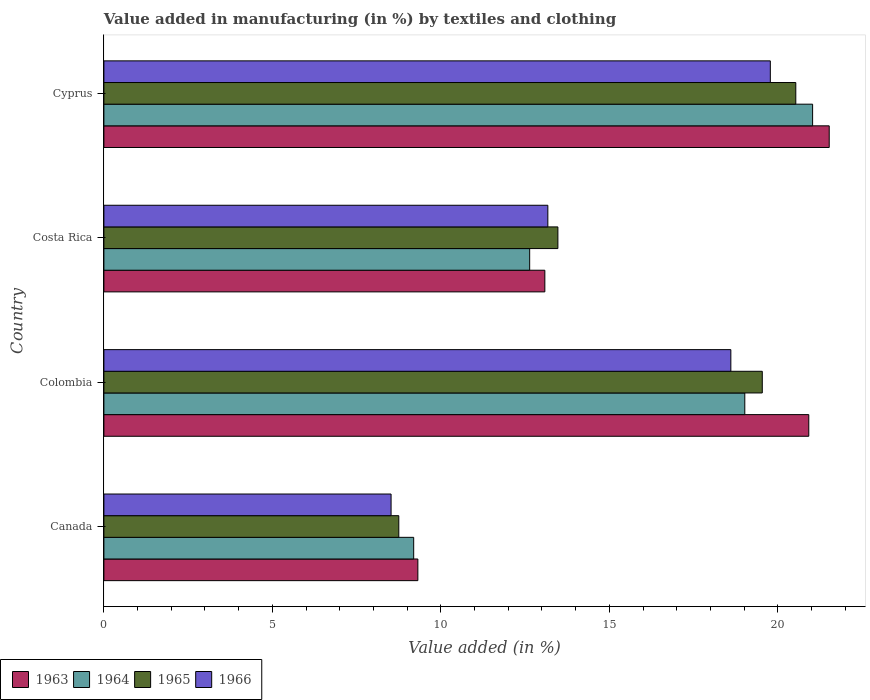Are the number of bars on each tick of the Y-axis equal?
Offer a terse response. Yes. How many bars are there on the 1st tick from the top?
Keep it short and to the point. 4. How many bars are there on the 3rd tick from the bottom?
Offer a terse response. 4. What is the label of the 3rd group of bars from the top?
Your answer should be very brief. Colombia. What is the percentage of value added in manufacturing by textiles and clothing in 1964 in Cyprus?
Ensure brevity in your answer.  21.03. Across all countries, what is the maximum percentage of value added in manufacturing by textiles and clothing in 1965?
Offer a terse response. 20.53. Across all countries, what is the minimum percentage of value added in manufacturing by textiles and clothing in 1964?
Keep it short and to the point. 9.19. In which country was the percentage of value added in manufacturing by textiles and clothing in 1963 maximum?
Your answer should be very brief. Cyprus. In which country was the percentage of value added in manufacturing by textiles and clothing in 1963 minimum?
Give a very brief answer. Canada. What is the total percentage of value added in manufacturing by textiles and clothing in 1963 in the graph?
Your answer should be very brief. 64.84. What is the difference between the percentage of value added in manufacturing by textiles and clothing in 1966 in Colombia and that in Cyprus?
Make the answer very short. -1.17. What is the difference between the percentage of value added in manufacturing by textiles and clothing in 1963 in Colombia and the percentage of value added in manufacturing by textiles and clothing in 1964 in Costa Rica?
Offer a very short reply. 8.28. What is the average percentage of value added in manufacturing by textiles and clothing in 1964 per country?
Provide a short and direct response. 15.47. What is the difference between the percentage of value added in manufacturing by textiles and clothing in 1966 and percentage of value added in manufacturing by textiles and clothing in 1964 in Colombia?
Your answer should be very brief. -0.41. In how many countries, is the percentage of value added in manufacturing by textiles and clothing in 1963 greater than 16 %?
Provide a succinct answer. 2. What is the ratio of the percentage of value added in manufacturing by textiles and clothing in 1964 in Colombia to that in Cyprus?
Your answer should be compact. 0.9. Is the difference between the percentage of value added in manufacturing by textiles and clothing in 1966 in Canada and Cyprus greater than the difference between the percentage of value added in manufacturing by textiles and clothing in 1964 in Canada and Cyprus?
Keep it short and to the point. Yes. What is the difference between the highest and the second highest percentage of value added in manufacturing by textiles and clothing in 1964?
Ensure brevity in your answer.  2.01. What is the difference between the highest and the lowest percentage of value added in manufacturing by textiles and clothing in 1965?
Offer a terse response. 11.78. In how many countries, is the percentage of value added in manufacturing by textiles and clothing in 1966 greater than the average percentage of value added in manufacturing by textiles and clothing in 1966 taken over all countries?
Give a very brief answer. 2. Is the sum of the percentage of value added in manufacturing by textiles and clothing in 1966 in Canada and Colombia greater than the maximum percentage of value added in manufacturing by textiles and clothing in 1964 across all countries?
Provide a short and direct response. Yes. What does the 1st bar from the top in Cyprus represents?
Provide a succinct answer. 1966. What does the 2nd bar from the bottom in Colombia represents?
Make the answer very short. 1964. Is it the case that in every country, the sum of the percentage of value added in manufacturing by textiles and clothing in 1964 and percentage of value added in manufacturing by textiles and clothing in 1963 is greater than the percentage of value added in manufacturing by textiles and clothing in 1966?
Your answer should be compact. Yes. How many bars are there?
Provide a succinct answer. 16. How many countries are there in the graph?
Offer a very short reply. 4. What is the difference between two consecutive major ticks on the X-axis?
Keep it short and to the point. 5. Are the values on the major ticks of X-axis written in scientific E-notation?
Your answer should be compact. No. Does the graph contain grids?
Provide a succinct answer. No. Where does the legend appear in the graph?
Your answer should be compact. Bottom left. How are the legend labels stacked?
Your answer should be very brief. Horizontal. What is the title of the graph?
Provide a succinct answer. Value added in manufacturing (in %) by textiles and clothing. Does "2000" appear as one of the legend labels in the graph?
Ensure brevity in your answer.  No. What is the label or title of the X-axis?
Your answer should be compact. Value added (in %). What is the label or title of the Y-axis?
Make the answer very short. Country. What is the Value added (in %) in 1963 in Canada?
Ensure brevity in your answer.  9.32. What is the Value added (in %) of 1964 in Canada?
Offer a very short reply. 9.19. What is the Value added (in %) of 1965 in Canada?
Offer a very short reply. 8.75. What is the Value added (in %) of 1966 in Canada?
Offer a very short reply. 8.52. What is the Value added (in %) in 1963 in Colombia?
Ensure brevity in your answer.  20.92. What is the Value added (in %) in 1964 in Colombia?
Your response must be concise. 19.02. What is the Value added (in %) in 1965 in Colombia?
Your answer should be compact. 19.54. What is the Value added (in %) in 1966 in Colombia?
Offer a terse response. 18.6. What is the Value added (in %) of 1963 in Costa Rica?
Offer a terse response. 13.08. What is the Value added (in %) in 1964 in Costa Rica?
Provide a succinct answer. 12.63. What is the Value added (in %) of 1965 in Costa Rica?
Offer a very short reply. 13.47. What is the Value added (in %) of 1966 in Costa Rica?
Offer a terse response. 13.17. What is the Value added (in %) of 1963 in Cyprus?
Provide a succinct answer. 21.52. What is the Value added (in %) of 1964 in Cyprus?
Your response must be concise. 21.03. What is the Value added (in %) of 1965 in Cyprus?
Make the answer very short. 20.53. What is the Value added (in %) in 1966 in Cyprus?
Provide a succinct answer. 19.78. Across all countries, what is the maximum Value added (in %) of 1963?
Offer a terse response. 21.52. Across all countries, what is the maximum Value added (in %) in 1964?
Your response must be concise. 21.03. Across all countries, what is the maximum Value added (in %) in 1965?
Your response must be concise. 20.53. Across all countries, what is the maximum Value added (in %) in 1966?
Ensure brevity in your answer.  19.78. Across all countries, what is the minimum Value added (in %) in 1963?
Keep it short and to the point. 9.32. Across all countries, what is the minimum Value added (in %) in 1964?
Your answer should be very brief. 9.19. Across all countries, what is the minimum Value added (in %) in 1965?
Your answer should be compact. 8.75. Across all countries, what is the minimum Value added (in %) of 1966?
Provide a short and direct response. 8.52. What is the total Value added (in %) of 1963 in the graph?
Offer a terse response. 64.84. What is the total Value added (in %) of 1964 in the graph?
Your response must be concise. 61.88. What is the total Value added (in %) in 1965 in the graph?
Make the answer very short. 62.29. What is the total Value added (in %) of 1966 in the graph?
Offer a terse response. 60.08. What is the difference between the Value added (in %) in 1963 in Canada and that in Colombia?
Offer a very short reply. -11.6. What is the difference between the Value added (in %) of 1964 in Canada and that in Colombia?
Make the answer very short. -9.82. What is the difference between the Value added (in %) of 1965 in Canada and that in Colombia?
Keep it short and to the point. -10.79. What is the difference between the Value added (in %) in 1966 in Canada and that in Colombia?
Give a very brief answer. -10.08. What is the difference between the Value added (in %) of 1963 in Canada and that in Costa Rica?
Your answer should be compact. -3.77. What is the difference between the Value added (in %) of 1964 in Canada and that in Costa Rica?
Provide a short and direct response. -3.44. What is the difference between the Value added (in %) of 1965 in Canada and that in Costa Rica?
Keep it short and to the point. -4.72. What is the difference between the Value added (in %) of 1966 in Canada and that in Costa Rica?
Give a very brief answer. -4.65. What is the difference between the Value added (in %) of 1963 in Canada and that in Cyprus?
Provide a succinct answer. -12.21. What is the difference between the Value added (in %) in 1964 in Canada and that in Cyprus?
Give a very brief answer. -11.84. What is the difference between the Value added (in %) in 1965 in Canada and that in Cyprus?
Ensure brevity in your answer.  -11.78. What is the difference between the Value added (in %) in 1966 in Canada and that in Cyprus?
Provide a succinct answer. -11.25. What is the difference between the Value added (in %) of 1963 in Colombia and that in Costa Rica?
Your response must be concise. 7.83. What is the difference between the Value added (in %) of 1964 in Colombia and that in Costa Rica?
Ensure brevity in your answer.  6.38. What is the difference between the Value added (in %) in 1965 in Colombia and that in Costa Rica?
Your answer should be compact. 6.06. What is the difference between the Value added (in %) in 1966 in Colombia and that in Costa Rica?
Give a very brief answer. 5.43. What is the difference between the Value added (in %) in 1963 in Colombia and that in Cyprus?
Offer a very short reply. -0.61. What is the difference between the Value added (in %) of 1964 in Colombia and that in Cyprus?
Offer a terse response. -2.01. What is the difference between the Value added (in %) in 1965 in Colombia and that in Cyprus?
Give a very brief answer. -0.99. What is the difference between the Value added (in %) in 1966 in Colombia and that in Cyprus?
Provide a short and direct response. -1.17. What is the difference between the Value added (in %) of 1963 in Costa Rica and that in Cyprus?
Give a very brief answer. -8.44. What is the difference between the Value added (in %) of 1964 in Costa Rica and that in Cyprus?
Offer a terse response. -8.4. What is the difference between the Value added (in %) in 1965 in Costa Rica and that in Cyprus?
Offer a terse response. -7.06. What is the difference between the Value added (in %) of 1966 in Costa Rica and that in Cyprus?
Your response must be concise. -6.6. What is the difference between the Value added (in %) in 1963 in Canada and the Value added (in %) in 1964 in Colombia?
Keep it short and to the point. -9.7. What is the difference between the Value added (in %) in 1963 in Canada and the Value added (in %) in 1965 in Colombia?
Your answer should be very brief. -10.22. What is the difference between the Value added (in %) in 1963 in Canada and the Value added (in %) in 1966 in Colombia?
Keep it short and to the point. -9.29. What is the difference between the Value added (in %) of 1964 in Canada and the Value added (in %) of 1965 in Colombia?
Provide a short and direct response. -10.34. What is the difference between the Value added (in %) in 1964 in Canada and the Value added (in %) in 1966 in Colombia?
Provide a succinct answer. -9.41. What is the difference between the Value added (in %) of 1965 in Canada and the Value added (in %) of 1966 in Colombia?
Provide a succinct answer. -9.85. What is the difference between the Value added (in %) of 1963 in Canada and the Value added (in %) of 1964 in Costa Rica?
Your answer should be compact. -3.32. What is the difference between the Value added (in %) of 1963 in Canada and the Value added (in %) of 1965 in Costa Rica?
Ensure brevity in your answer.  -4.16. What is the difference between the Value added (in %) in 1963 in Canada and the Value added (in %) in 1966 in Costa Rica?
Provide a short and direct response. -3.86. What is the difference between the Value added (in %) of 1964 in Canada and the Value added (in %) of 1965 in Costa Rica?
Provide a short and direct response. -4.28. What is the difference between the Value added (in %) of 1964 in Canada and the Value added (in %) of 1966 in Costa Rica?
Give a very brief answer. -3.98. What is the difference between the Value added (in %) of 1965 in Canada and the Value added (in %) of 1966 in Costa Rica?
Offer a very short reply. -4.42. What is the difference between the Value added (in %) in 1963 in Canada and the Value added (in %) in 1964 in Cyprus?
Offer a very short reply. -11.71. What is the difference between the Value added (in %) of 1963 in Canada and the Value added (in %) of 1965 in Cyprus?
Provide a succinct answer. -11.21. What is the difference between the Value added (in %) of 1963 in Canada and the Value added (in %) of 1966 in Cyprus?
Keep it short and to the point. -10.46. What is the difference between the Value added (in %) of 1964 in Canada and the Value added (in %) of 1965 in Cyprus?
Provide a short and direct response. -11.34. What is the difference between the Value added (in %) of 1964 in Canada and the Value added (in %) of 1966 in Cyprus?
Offer a terse response. -10.58. What is the difference between the Value added (in %) of 1965 in Canada and the Value added (in %) of 1966 in Cyprus?
Provide a short and direct response. -11.02. What is the difference between the Value added (in %) of 1963 in Colombia and the Value added (in %) of 1964 in Costa Rica?
Provide a succinct answer. 8.28. What is the difference between the Value added (in %) of 1963 in Colombia and the Value added (in %) of 1965 in Costa Rica?
Make the answer very short. 7.44. What is the difference between the Value added (in %) of 1963 in Colombia and the Value added (in %) of 1966 in Costa Rica?
Make the answer very short. 7.74. What is the difference between the Value added (in %) of 1964 in Colombia and the Value added (in %) of 1965 in Costa Rica?
Your answer should be compact. 5.55. What is the difference between the Value added (in %) of 1964 in Colombia and the Value added (in %) of 1966 in Costa Rica?
Make the answer very short. 5.84. What is the difference between the Value added (in %) of 1965 in Colombia and the Value added (in %) of 1966 in Costa Rica?
Offer a terse response. 6.36. What is the difference between the Value added (in %) of 1963 in Colombia and the Value added (in %) of 1964 in Cyprus?
Provide a short and direct response. -0.11. What is the difference between the Value added (in %) of 1963 in Colombia and the Value added (in %) of 1965 in Cyprus?
Give a very brief answer. 0.39. What is the difference between the Value added (in %) in 1963 in Colombia and the Value added (in %) in 1966 in Cyprus?
Your answer should be very brief. 1.14. What is the difference between the Value added (in %) of 1964 in Colombia and the Value added (in %) of 1965 in Cyprus?
Your answer should be compact. -1.51. What is the difference between the Value added (in %) in 1964 in Colombia and the Value added (in %) in 1966 in Cyprus?
Keep it short and to the point. -0.76. What is the difference between the Value added (in %) of 1965 in Colombia and the Value added (in %) of 1966 in Cyprus?
Your answer should be compact. -0.24. What is the difference between the Value added (in %) of 1963 in Costa Rica and the Value added (in %) of 1964 in Cyprus?
Offer a terse response. -7.95. What is the difference between the Value added (in %) of 1963 in Costa Rica and the Value added (in %) of 1965 in Cyprus?
Ensure brevity in your answer.  -7.45. What is the difference between the Value added (in %) of 1963 in Costa Rica and the Value added (in %) of 1966 in Cyprus?
Keep it short and to the point. -6.69. What is the difference between the Value added (in %) of 1964 in Costa Rica and the Value added (in %) of 1965 in Cyprus?
Ensure brevity in your answer.  -7.9. What is the difference between the Value added (in %) in 1964 in Costa Rica and the Value added (in %) in 1966 in Cyprus?
Give a very brief answer. -7.14. What is the difference between the Value added (in %) of 1965 in Costa Rica and the Value added (in %) of 1966 in Cyprus?
Make the answer very short. -6.3. What is the average Value added (in %) in 1963 per country?
Provide a short and direct response. 16.21. What is the average Value added (in %) in 1964 per country?
Your answer should be compact. 15.47. What is the average Value added (in %) of 1965 per country?
Ensure brevity in your answer.  15.57. What is the average Value added (in %) in 1966 per country?
Your answer should be compact. 15.02. What is the difference between the Value added (in %) of 1963 and Value added (in %) of 1964 in Canada?
Give a very brief answer. 0.12. What is the difference between the Value added (in %) in 1963 and Value added (in %) in 1965 in Canada?
Keep it short and to the point. 0.57. What is the difference between the Value added (in %) in 1963 and Value added (in %) in 1966 in Canada?
Offer a terse response. 0.8. What is the difference between the Value added (in %) in 1964 and Value added (in %) in 1965 in Canada?
Your response must be concise. 0.44. What is the difference between the Value added (in %) in 1964 and Value added (in %) in 1966 in Canada?
Give a very brief answer. 0.67. What is the difference between the Value added (in %) of 1965 and Value added (in %) of 1966 in Canada?
Your answer should be compact. 0.23. What is the difference between the Value added (in %) of 1963 and Value added (in %) of 1964 in Colombia?
Make the answer very short. 1.9. What is the difference between the Value added (in %) in 1963 and Value added (in %) in 1965 in Colombia?
Keep it short and to the point. 1.38. What is the difference between the Value added (in %) of 1963 and Value added (in %) of 1966 in Colombia?
Your answer should be compact. 2.31. What is the difference between the Value added (in %) in 1964 and Value added (in %) in 1965 in Colombia?
Your response must be concise. -0.52. What is the difference between the Value added (in %) in 1964 and Value added (in %) in 1966 in Colombia?
Make the answer very short. 0.41. What is the difference between the Value added (in %) of 1965 and Value added (in %) of 1966 in Colombia?
Your answer should be very brief. 0.93. What is the difference between the Value added (in %) of 1963 and Value added (in %) of 1964 in Costa Rica?
Your answer should be very brief. 0.45. What is the difference between the Value added (in %) in 1963 and Value added (in %) in 1965 in Costa Rica?
Give a very brief answer. -0.39. What is the difference between the Value added (in %) in 1963 and Value added (in %) in 1966 in Costa Rica?
Keep it short and to the point. -0.09. What is the difference between the Value added (in %) of 1964 and Value added (in %) of 1965 in Costa Rica?
Offer a very short reply. -0.84. What is the difference between the Value added (in %) in 1964 and Value added (in %) in 1966 in Costa Rica?
Provide a short and direct response. -0.54. What is the difference between the Value added (in %) in 1965 and Value added (in %) in 1966 in Costa Rica?
Ensure brevity in your answer.  0.3. What is the difference between the Value added (in %) in 1963 and Value added (in %) in 1964 in Cyprus?
Give a very brief answer. 0.49. What is the difference between the Value added (in %) of 1963 and Value added (in %) of 1966 in Cyprus?
Your answer should be compact. 1.75. What is the difference between the Value added (in %) in 1964 and Value added (in %) in 1965 in Cyprus?
Ensure brevity in your answer.  0.5. What is the difference between the Value added (in %) in 1964 and Value added (in %) in 1966 in Cyprus?
Offer a very short reply. 1.25. What is the difference between the Value added (in %) of 1965 and Value added (in %) of 1966 in Cyprus?
Provide a short and direct response. 0.76. What is the ratio of the Value added (in %) in 1963 in Canada to that in Colombia?
Ensure brevity in your answer.  0.45. What is the ratio of the Value added (in %) in 1964 in Canada to that in Colombia?
Your answer should be very brief. 0.48. What is the ratio of the Value added (in %) in 1965 in Canada to that in Colombia?
Provide a succinct answer. 0.45. What is the ratio of the Value added (in %) of 1966 in Canada to that in Colombia?
Offer a very short reply. 0.46. What is the ratio of the Value added (in %) of 1963 in Canada to that in Costa Rica?
Make the answer very short. 0.71. What is the ratio of the Value added (in %) in 1964 in Canada to that in Costa Rica?
Offer a terse response. 0.73. What is the ratio of the Value added (in %) of 1965 in Canada to that in Costa Rica?
Provide a short and direct response. 0.65. What is the ratio of the Value added (in %) in 1966 in Canada to that in Costa Rica?
Your response must be concise. 0.65. What is the ratio of the Value added (in %) in 1963 in Canada to that in Cyprus?
Make the answer very short. 0.43. What is the ratio of the Value added (in %) in 1964 in Canada to that in Cyprus?
Make the answer very short. 0.44. What is the ratio of the Value added (in %) of 1965 in Canada to that in Cyprus?
Keep it short and to the point. 0.43. What is the ratio of the Value added (in %) of 1966 in Canada to that in Cyprus?
Provide a succinct answer. 0.43. What is the ratio of the Value added (in %) in 1963 in Colombia to that in Costa Rica?
Ensure brevity in your answer.  1.6. What is the ratio of the Value added (in %) of 1964 in Colombia to that in Costa Rica?
Your response must be concise. 1.51. What is the ratio of the Value added (in %) of 1965 in Colombia to that in Costa Rica?
Provide a short and direct response. 1.45. What is the ratio of the Value added (in %) of 1966 in Colombia to that in Costa Rica?
Offer a terse response. 1.41. What is the ratio of the Value added (in %) in 1963 in Colombia to that in Cyprus?
Your answer should be very brief. 0.97. What is the ratio of the Value added (in %) in 1964 in Colombia to that in Cyprus?
Offer a terse response. 0.9. What is the ratio of the Value added (in %) of 1965 in Colombia to that in Cyprus?
Ensure brevity in your answer.  0.95. What is the ratio of the Value added (in %) of 1966 in Colombia to that in Cyprus?
Ensure brevity in your answer.  0.94. What is the ratio of the Value added (in %) in 1963 in Costa Rica to that in Cyprus?
Keep it short and to the point. 0.61. What is the ratio of the Value added (in %) in 1964 in Costa Rica to that in Cyprus?
Keep it short and to the point. 0.6. What is the ratio of the Value added (in %) of 1965 in Costa Rica to that in Cyprus?
Ensure brevity in your answer.  0.66. What is the ratio of the Value added (in %) in 1966 in Costa Rica to that in Cyprus?
Offer a very short reply. 0.67. What is the difference between the highest and the second highest Value added (in %) of 1963?
Offer a terse response. 0.61. What is the difference between the highest and the second highest Value added (in %) in 1964?
Your answer should be very brief. 2.01. What is the difference between the highest and the second highest Value added (in %) in 1966?
Offer a very short reply. 1.17. What is the difference between the highest and the lowest Value added (in %) of 1963?
Your answer should be compact. 12.21. What is the difference between the highest and the lowest Value added (in %) in 1964?
Provide a succinct answer. 11.84. What is the difference between the highest and the lowest Value added (in %) in 1965?
Keep it short and to the point. 11.78. What is the difference between the highest and the lowest Value added (in %) of 1966?
Provide a short and direct response. 11.25. 